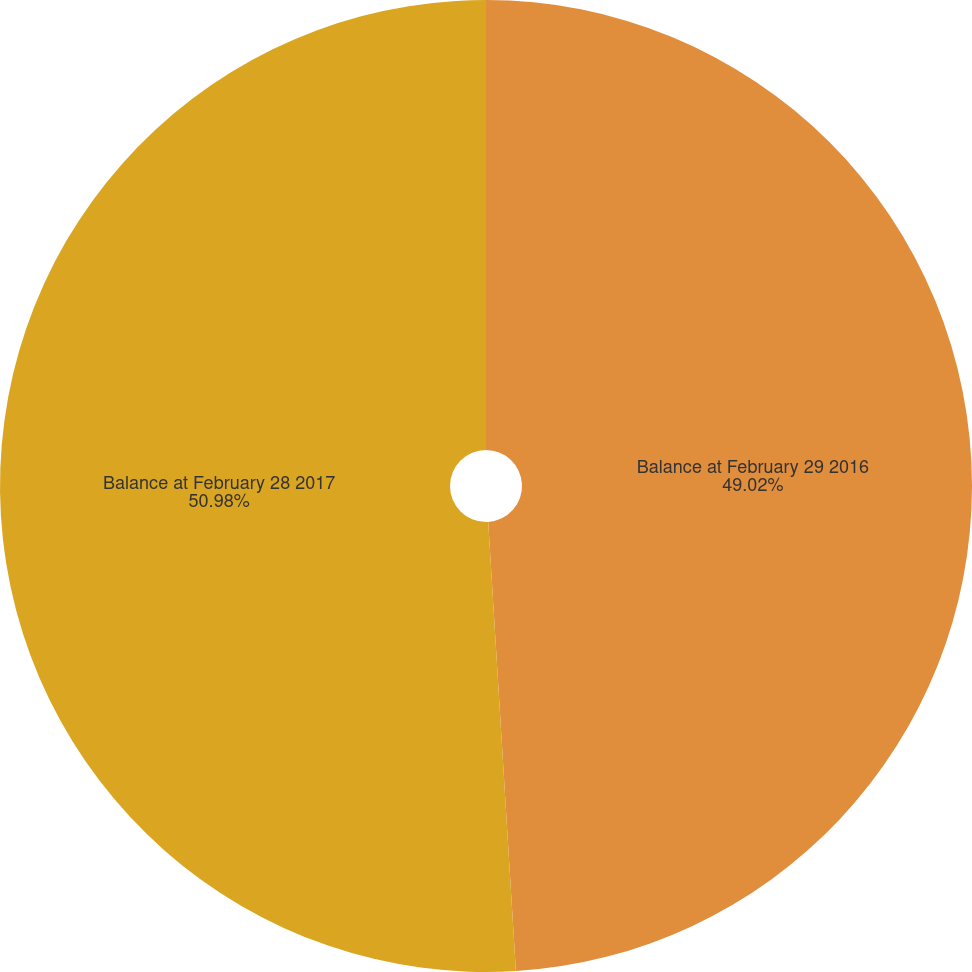Convert chart. <chart><loc_0><loc_0><loc_500><loc_500><pie_chart><fcel>Balance at February 29 2016<fcel>Balance at February 28 2017<nl><fcel>49.02%<fcel>50.98%<nl></chart> 